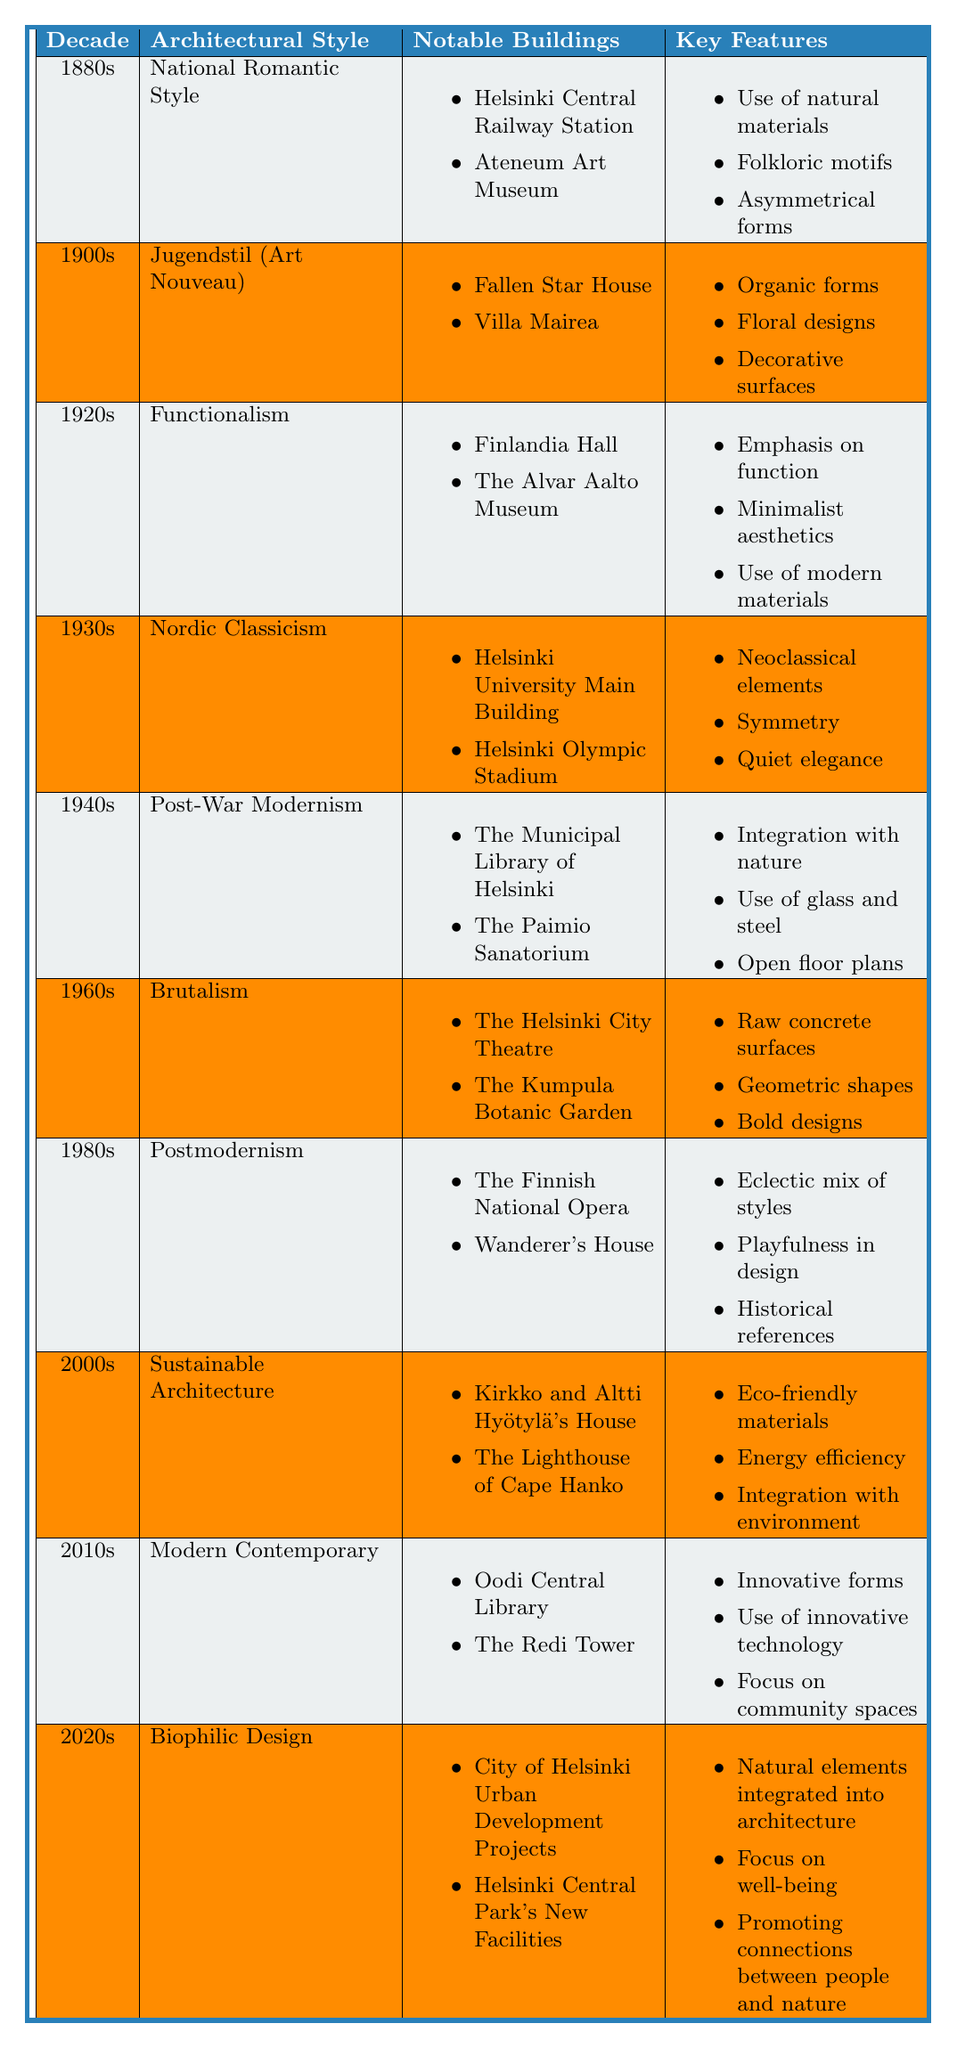What architectural style was prominent in the 1940s? The 1940s featured the "Post-War Modernism" architectural style. This can be identified by checking the decade column and corresponding style.
Answer: Post-War Modernism How many notable buildings are associated with the 1920s? The 1920s has two notable buildings listed: "Finlandia Hall" and "The Alvar Aalto Museum". Therefore, the count is two.
Answer: 2 Is "Brutalism" listed as an architectural style in the 1960s? Yes, "Brutalism" is indeed listed as an architectural style for the 1960s, as per the style in that specific decade's row.
Answer: Yes Which architectural style is characterized by natural materials and folkloric motifs? This describes the "National Romantic Style" from the 1880s, based on the keywords associated with that style in the table.
Answer: National Romantic Style Compare the key features of "Functionalism" and "Postmodernism." "Functionalism" emphasizes function and minimalist aesthetics, while "Postmodernism" features an eclectic mix of styles and playfulness in design. Both can be analyzed by checking their respective key features in the table.
Answer: Functionality vs. Eclecticism What is the key feature of "Sustainable Architecture" that relates to environmental concerns? A key feature is "eco-friendly materials," which directly relates to environmental concerns. Checking this feature under the 2000s, it is clear this is a focus area.
Answer: Eco-friendly materials Which decade introduced "Biophilic Design," and what is one of its notable buildings? "Biophilic Design" is introduced in the 2020s, with "City of Helsinki Urban Development Projects" as one of its notable buildings, found by locating this style in the respective decade's row.
Answer: 2020s, City of Helsinki Urban Development Projects How many architectural styles were recognized in the 1930s? There was one architectural style recognized in the 1930s, which is "Nordic Classicism." This can be concluded by checking the number of styles listed in that decade’s row.
Answer: 1 Are there any architectural styles from the 2000s related to energy efficiency? Yes, "Sustainable Architecture" from the 2000s is related to energy efficiency, identified by reviewing the key features of that style.
Answer: Yes What notable building can be associated with Jugendstil? "Villa Mairea" is a notable building associated with Jugendstil, found by looking under the 1900s column for this style.
Answer: Villa Mairea 